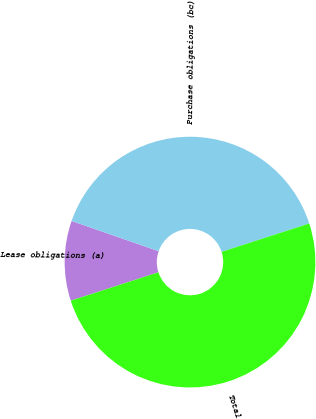Convert chart to OTSL. <chart><loc_0><loc_0><loc_500><loc_500><pie_chart><fcel>Lease obligations (a)<fcel>Purchase obligations (bc)<fcel>Total<nl><fcel>10.31%<fcel>39.69%<fcel>50.0%<nl></chart> 